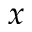<formula> <loc_0><loc_0><loc_500><loc_500>x</formula> 